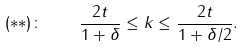Convert formula to latex. <formula><loc_0><loc_0><loc_500><loc_500>( * * ) \colon \quad \frac { 2 t } { 1 + \delta } \leq k \leq \frac { 2 t } { 1 + \delta / 2 } .</formula> 